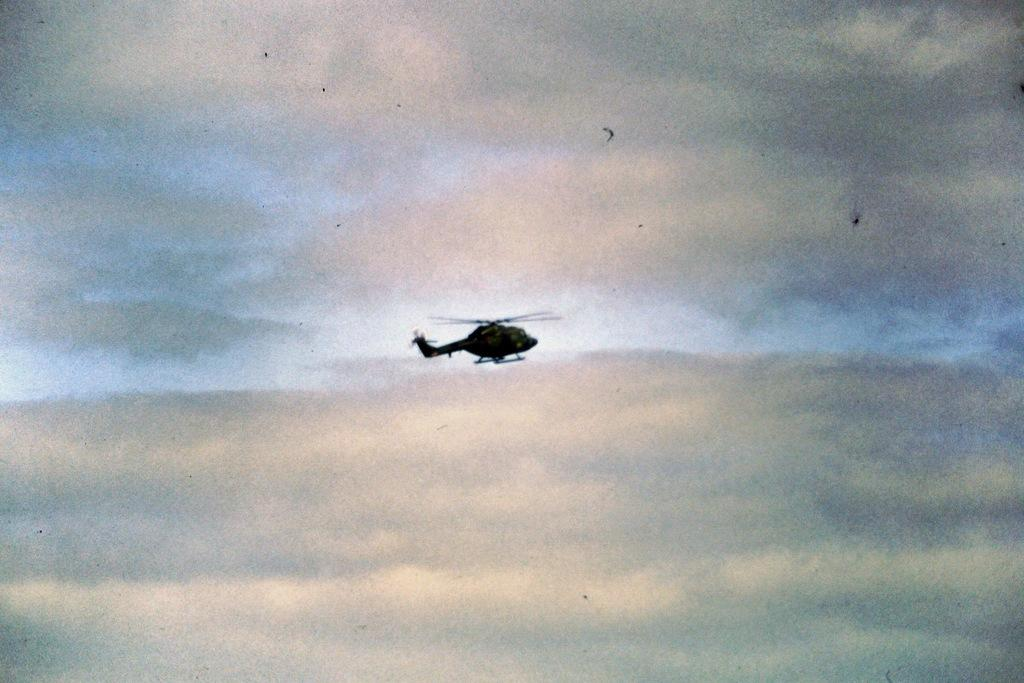What is the main subject in the center of the image? There is a helicopter in the center of the image. What can be seen in the background of the image? The sky is visible in the background of the image. What type of tin can be seen in the image? There is no tin present in the image. Can you describe the scent of the helicopter in the image? The image does not provide any information about the scent of the helicopter, as it is a visual medium. 